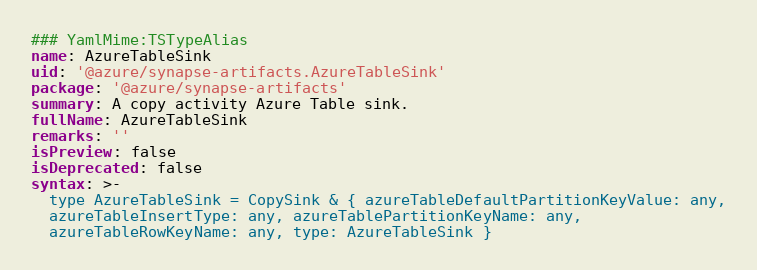Convert code to text. <code><loc_0><loc_0><loc_500><loc_500><_YAML_>### YamlMime:TSTypeAlias
name: AzureTableSink
uid: '@azure/synapse-artifacts.AzureTableSink'
package: '@azure/synapse-artifacts'
summary: A copy activity Azure Table sink.
fullName: AzureTableSink
remarks: ''
isPreview: false
isDeprecated: false
syntax: >-
  type AzureTableSink = CopySink & { azureTableDefaultPartitionKeyValue: any,
  azureTableInsertType: any, azureTablePartitionKeyName: any,
  azureTableRowKeyName: any, type: AzureTableSink }
</code> 